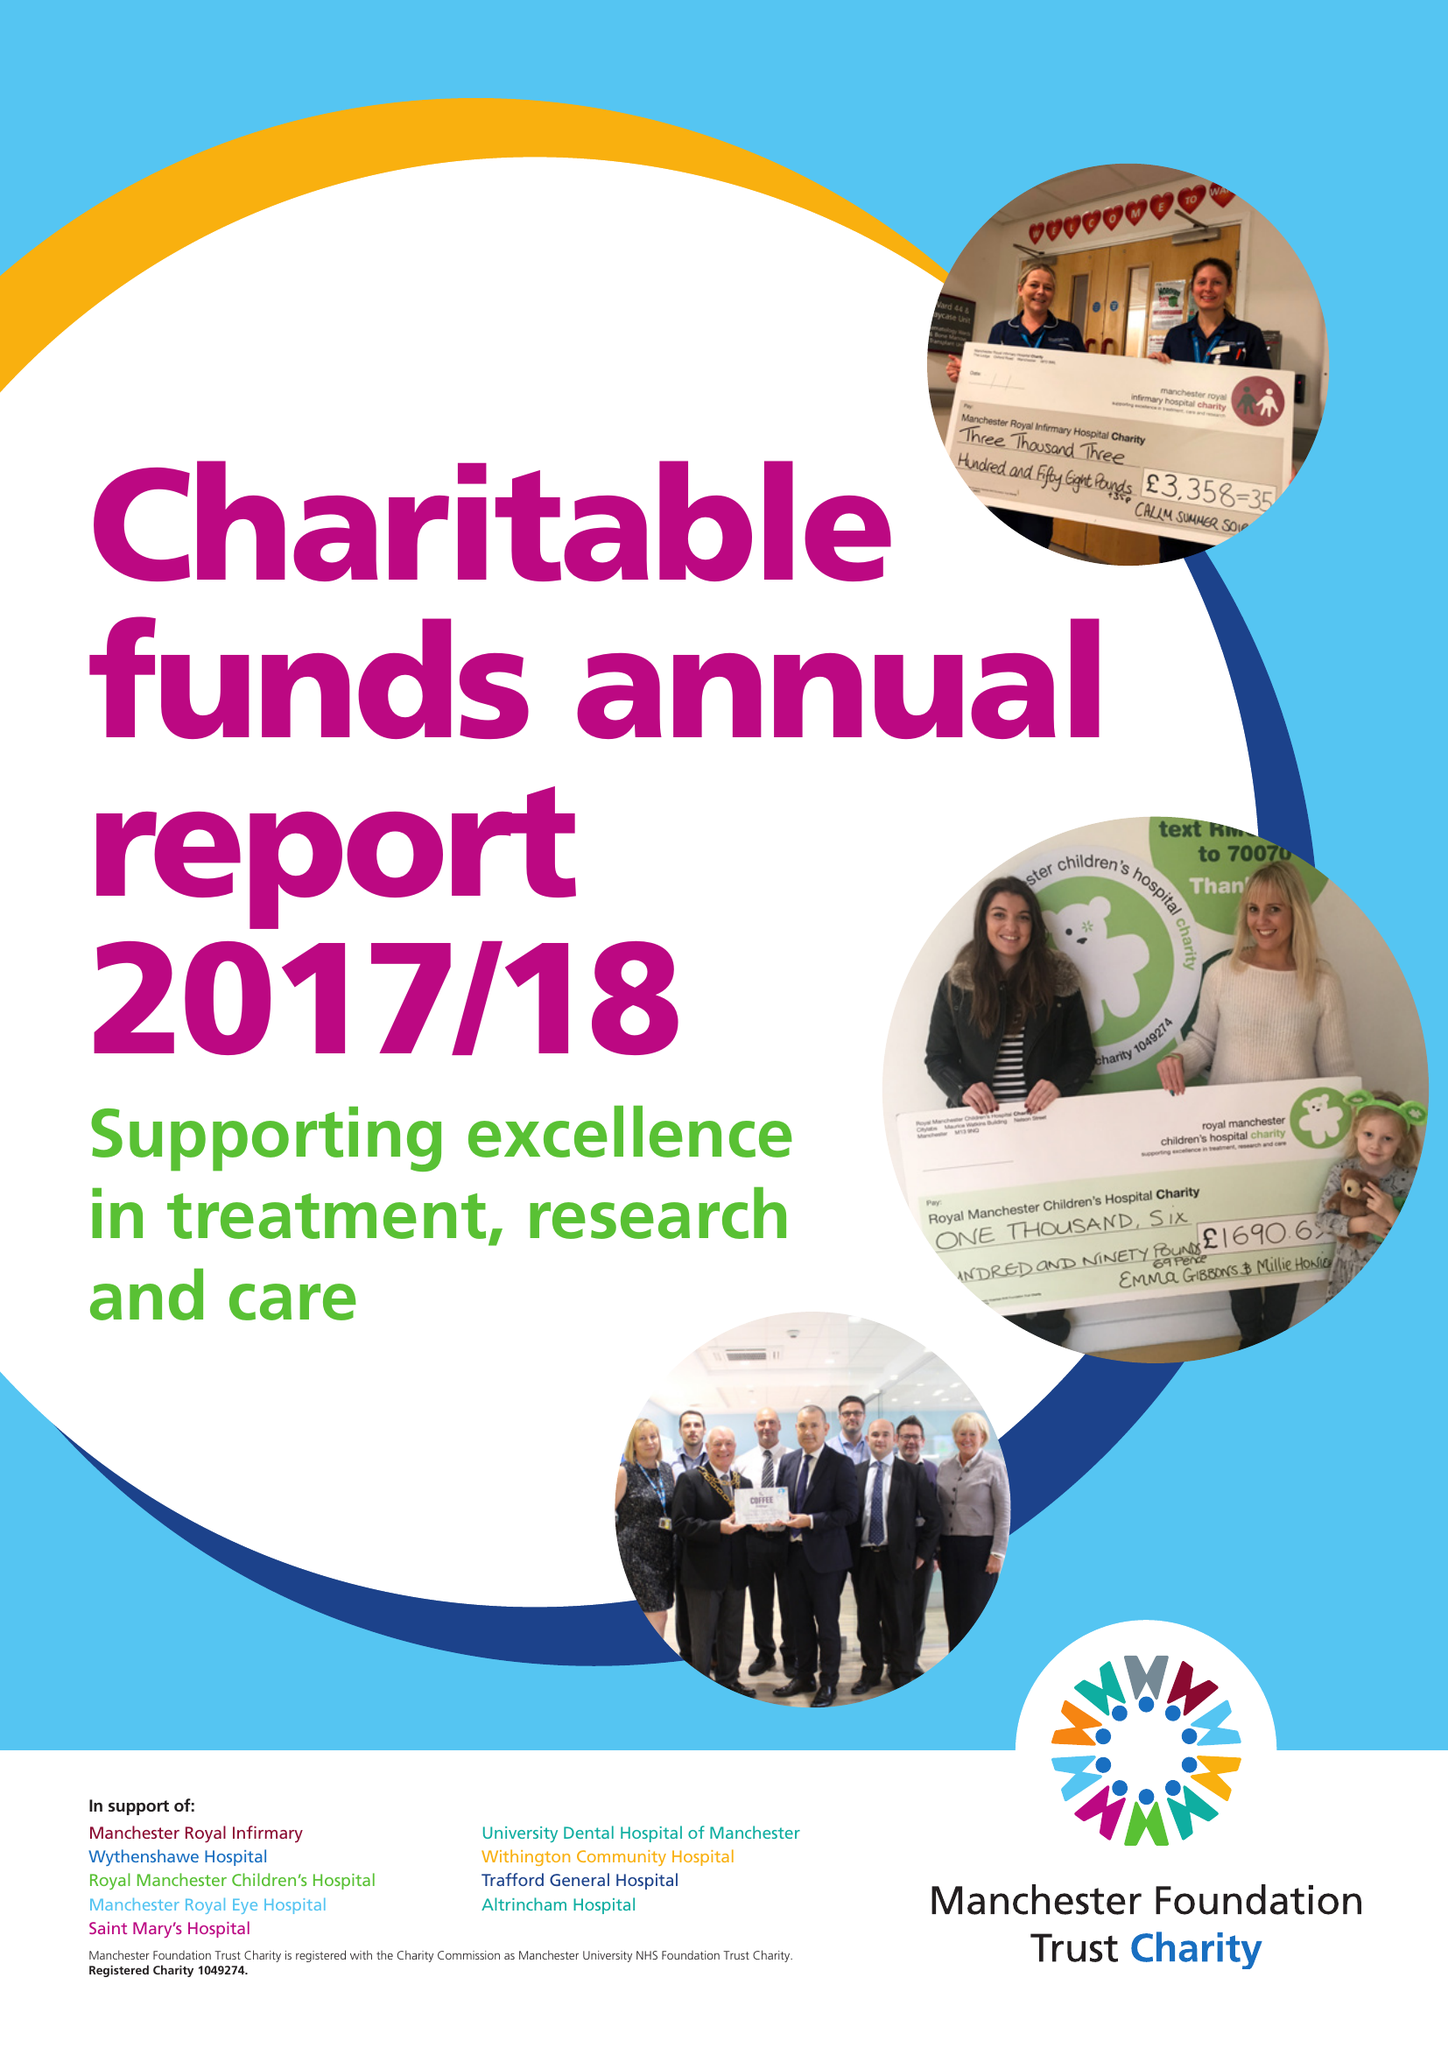What is the value for the charity_number?
Answer the question using a single word or phrase. 1049274 